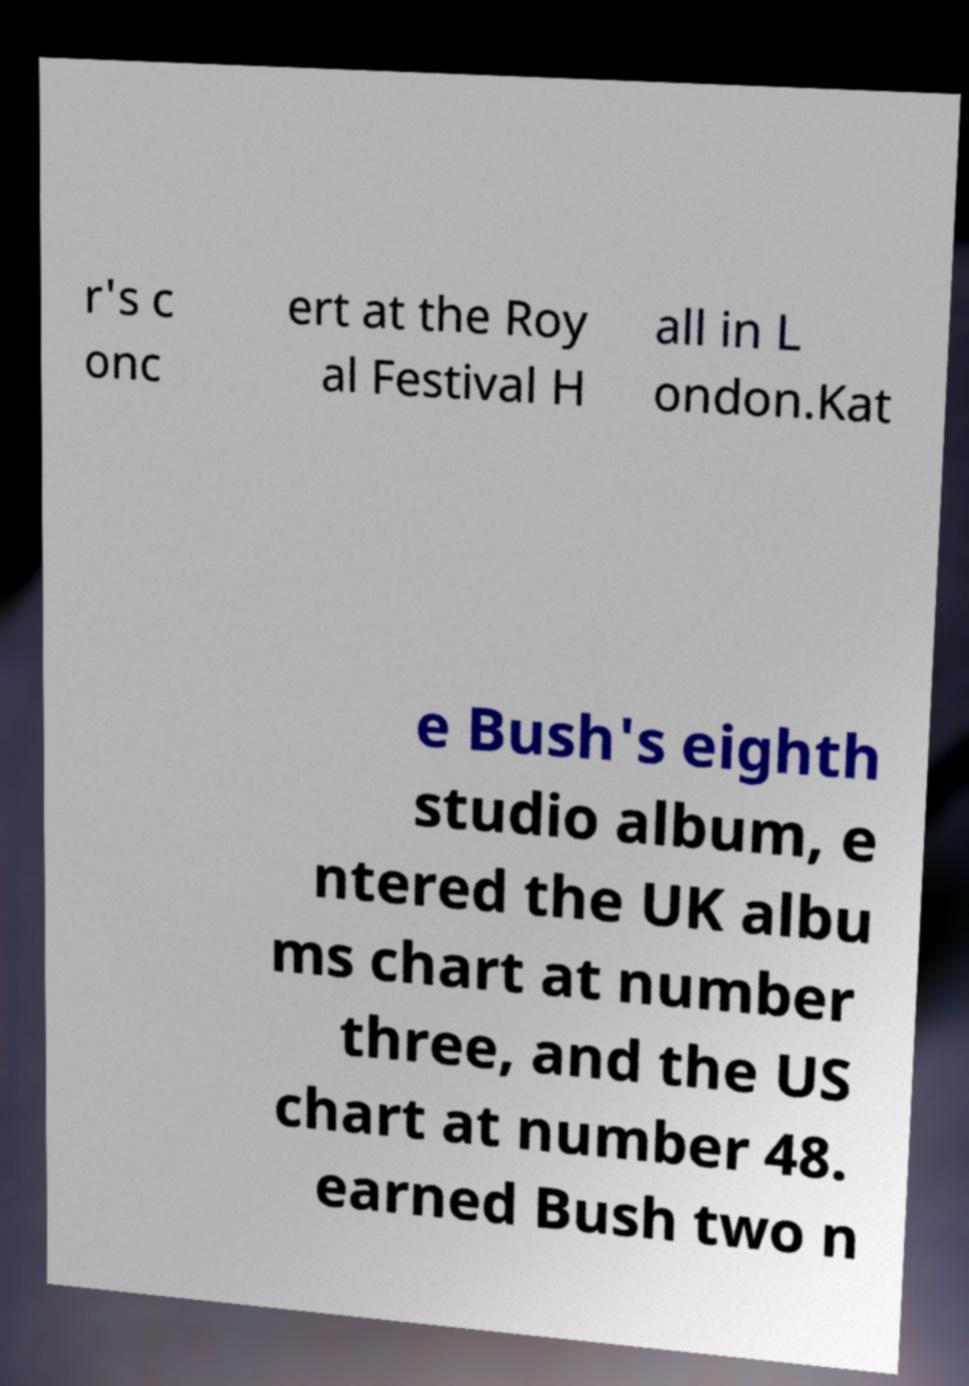Please identify and transcribe the text found in this image. r's c onc ert at the Roy al Festival H all in L ondon.Kat e Bush's eighth studio album, e ntered the UK albu ms chart at number three, and the US chart at number 48. earned Bush two n 